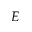<formula> <loc_0><loc_0><loc_500><loc_500>E</formula> 